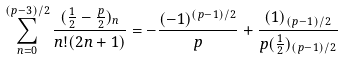<formula> <loc_0><loc_0><loc_500><loc_500>\sum _ { n = 0 } ^ { ( p - 3 ) / 2 } \frac { ( \frac { 1 } { 2 } - \frac { p } { 2 } ) _ { n } } { n ! ( 2 n + 1 ) } = - \frac { ( - 1 ) ^ { ( p - 1 ) / 2 } } p + \frac { ( 1 ) _ { ( p - 1 ) / 2 } } { p ( \frac { 1 } { 2 } ) _ { ( p - 1 ) / 2 } }</formula> 